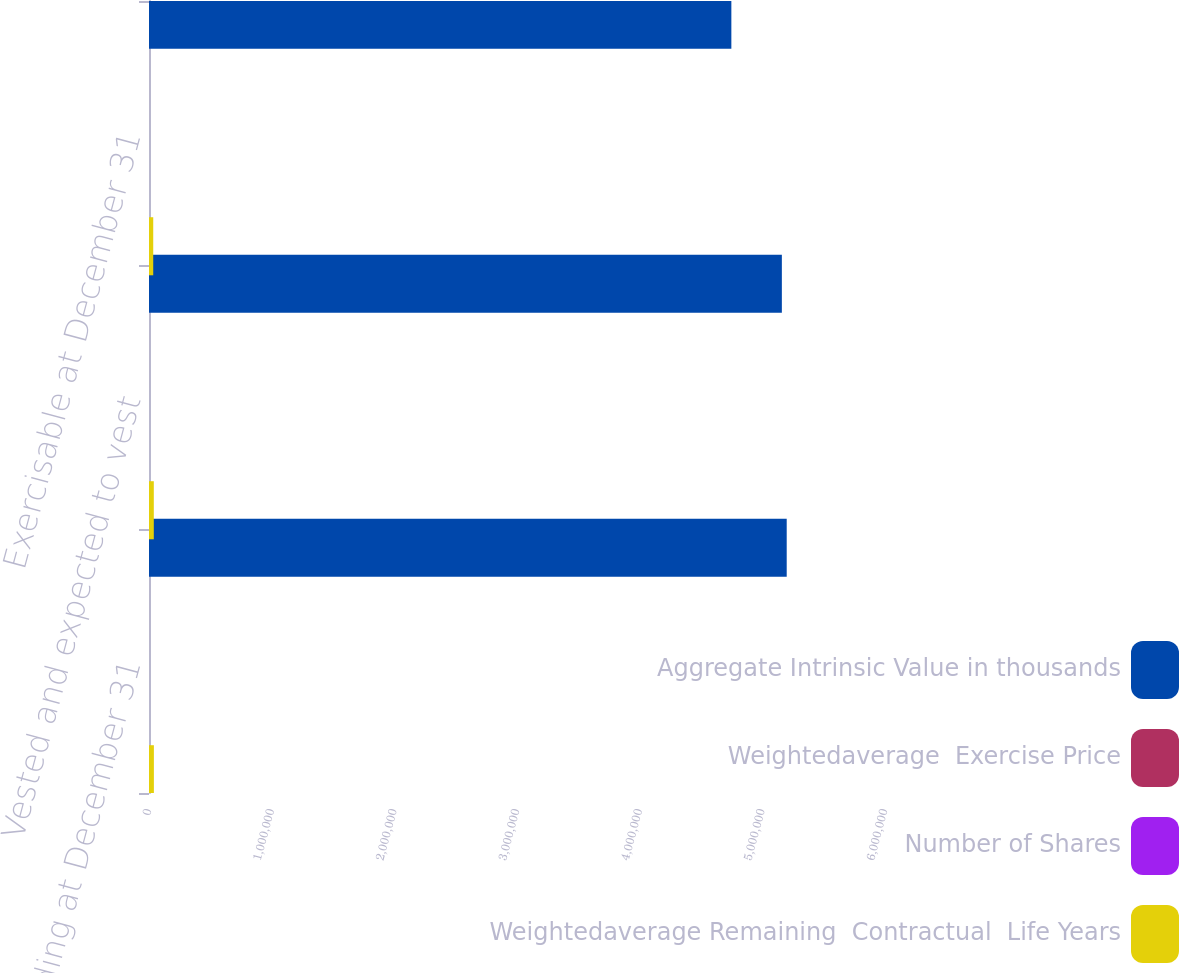<chart> <loc_0><loc_0><loc_500><loc_500><stacked_bar_chart><ecel><fcel>Outstanding at December 31<fcel>Vested and expected to vest<fcel>Exercisable at December 31<nl><fcel>Aggregate Intrinsic Value in thousands<fcel>5.19875e+06<fcel>5.15918e+06<fcel>4.74747e+06<nl><fcel>Weightedaverage  Exercise Price<fcel>58.59<fcel>58.71<fcel>59.64<nl><fcel>Number of Shares<fcel>4.09<fcel>4.06<fcel>3.69<nl><fcel>Weightedaverage Remaining  Contractual  Life Years<fcel>39799<fcel>39134<fcel>34520<nl></chart> 